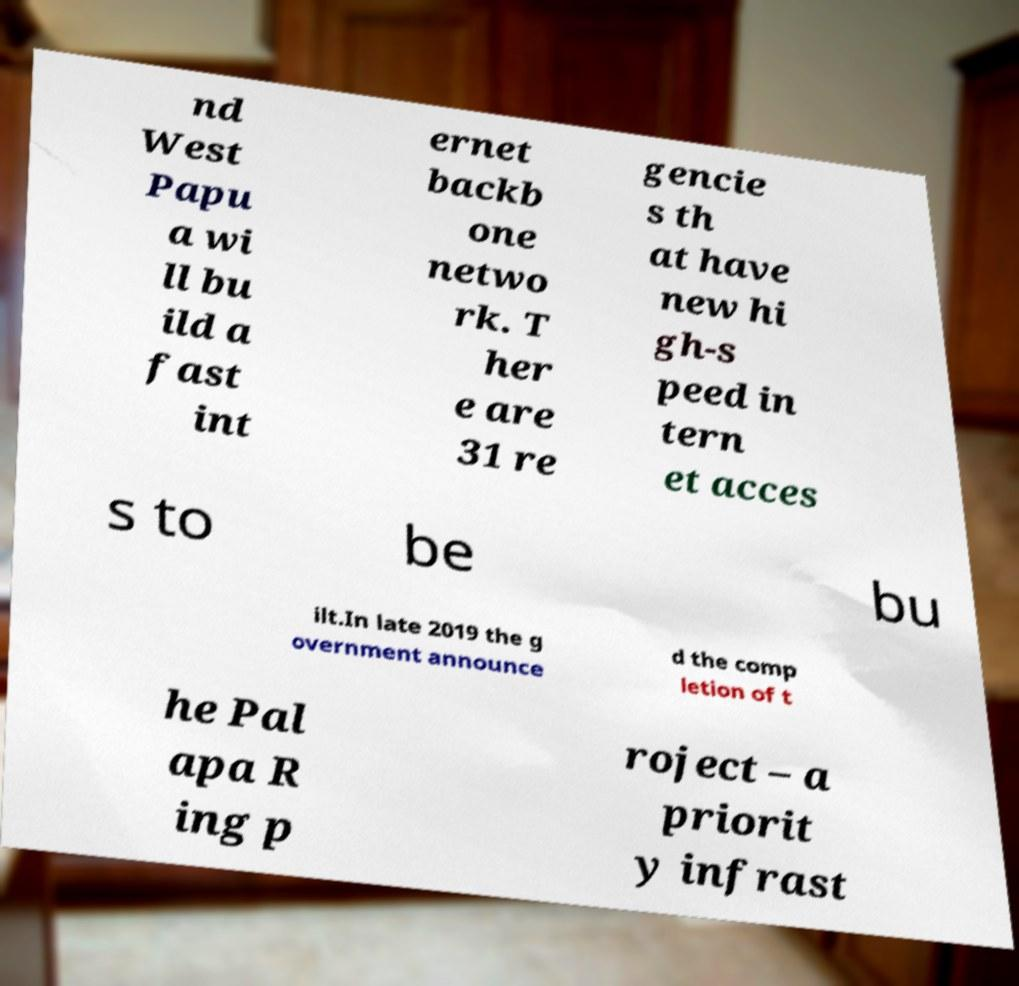What messages or text are displayed in this image? I need them in a readable, typed format. nd West Papu a wi ll bu ild a fast int ernet backb one netwo rk. T her e are 31 re gencie s th at have new hi gh-s peed in tern et acces s to be bu ilt.In late 2019 the g overnment announce d the comp letion of t he Pal apa R ing p roject – a priorit y infrast 